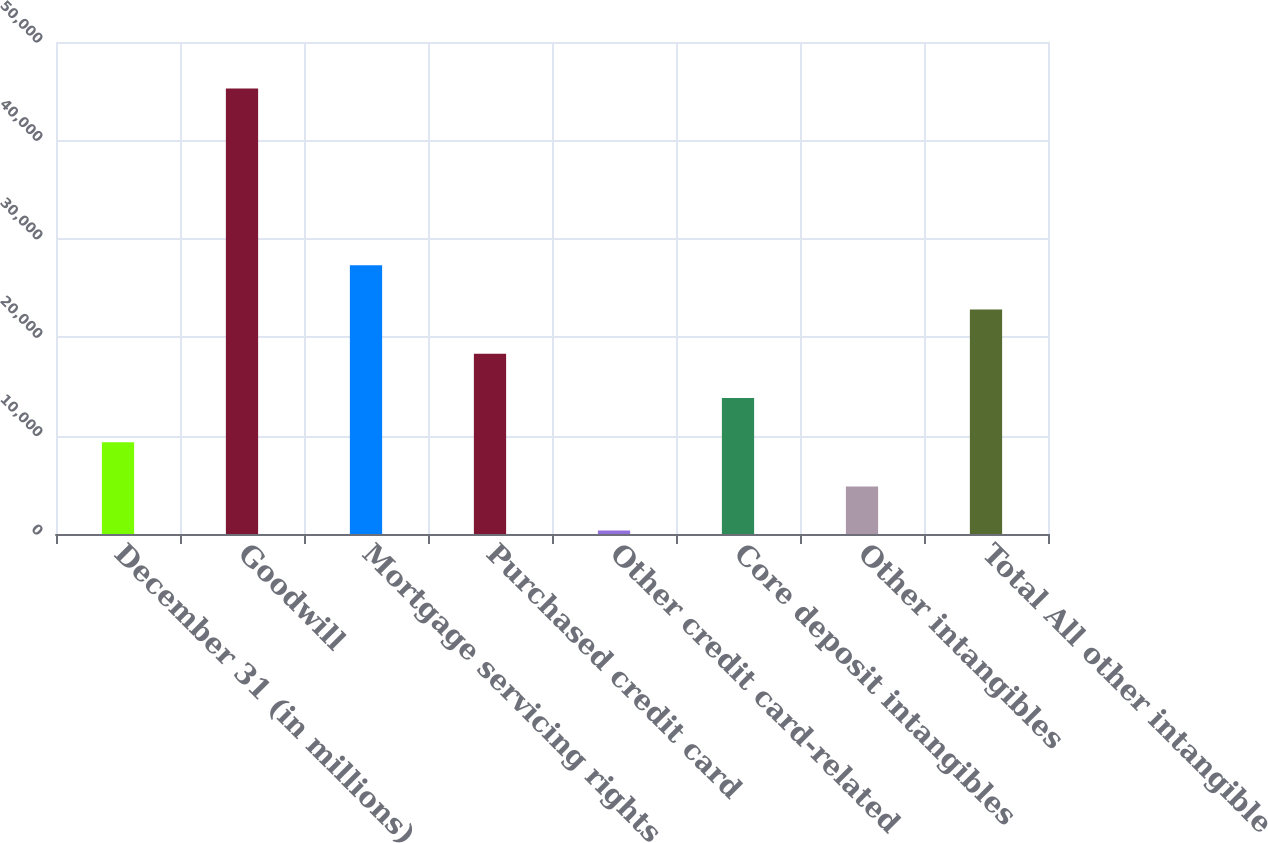<chart> <loc_0><loc_0><loc_500><loc_500><bar_chart><fcel>December 31 (in millions)<fcel>Goodwill<fcel>Mortgage servicing rights<fcel>Purchased credit card<fcel>Other credit card-related<fcel>Core deposit intangibles<fcel>Other intangibles<fcel>Total All other intangible<nl><fcel>9330.8<fcel>45270<fcel>27300.4<fcel>18315.6<fcel>346<fcel>13823.2<fcel>4838.4<fcel>22808<nl></chart> 